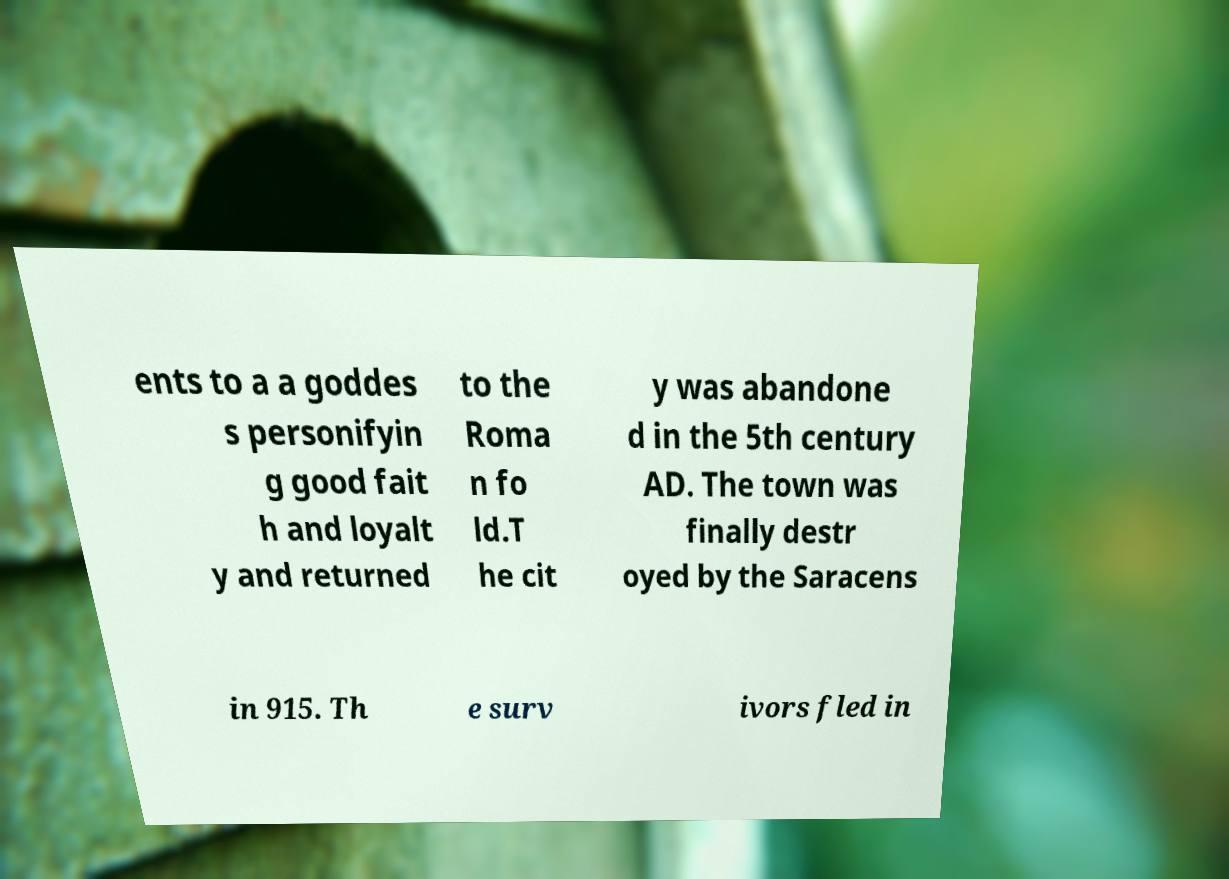Can you read and provide the text displayed in the image?This photo seems to have some interesting text. Can you extract and type it out for me? ents to a a goddes s personifyin g good fait h and loyalt y and returned to the Roma n fo ld.T he cit y was abandone d in the 5th century AD. The town was finally destr oyed by the Saracens in 915. Th e surv ivors fled in 